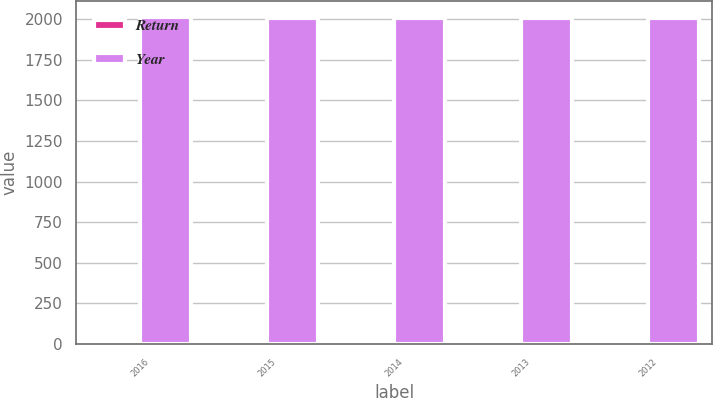Convert chart. <chart><loc_0><loc_0><loc_500><loc_500><stacked_bar_chart><ecel><fcel>2016<fcel>2015<fcel>2014<fcel>2013<fcel>2012<nl><fcel>Return<fcel>7.1<fcel>1.3<fcel>6.4<fcel>14.1<fcel>14.1<nl><fcel>Year<fcel>2011<fcel>2010<fcel>2009<fcel>2008<fcel>2007<nl></chart> 